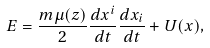Convert formula to latex. <formula><loc_0><loc_0><loc_500><loc_500>E = \frac { m \mu ( z ) } { 2 } \frac { d x ^ { i } } { d t } \frac { d x _ { i } } { d t } + U ( x ) ,</formula> 